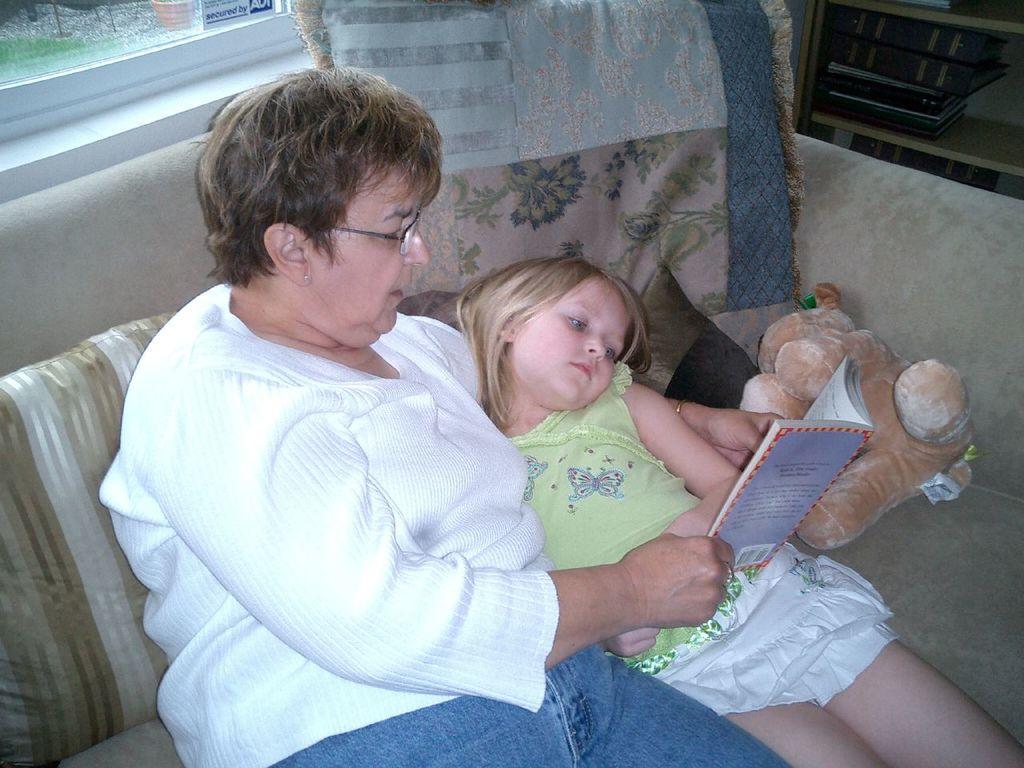Describe this image in one or two sentences. There is a woman and a girl. Woman is wearing a specs and holding a book. They are sitting on a sofa. On the sofa there are pillows and a teddy bear. In the back there is a window. In the right top corner there is a cupboard with books. 